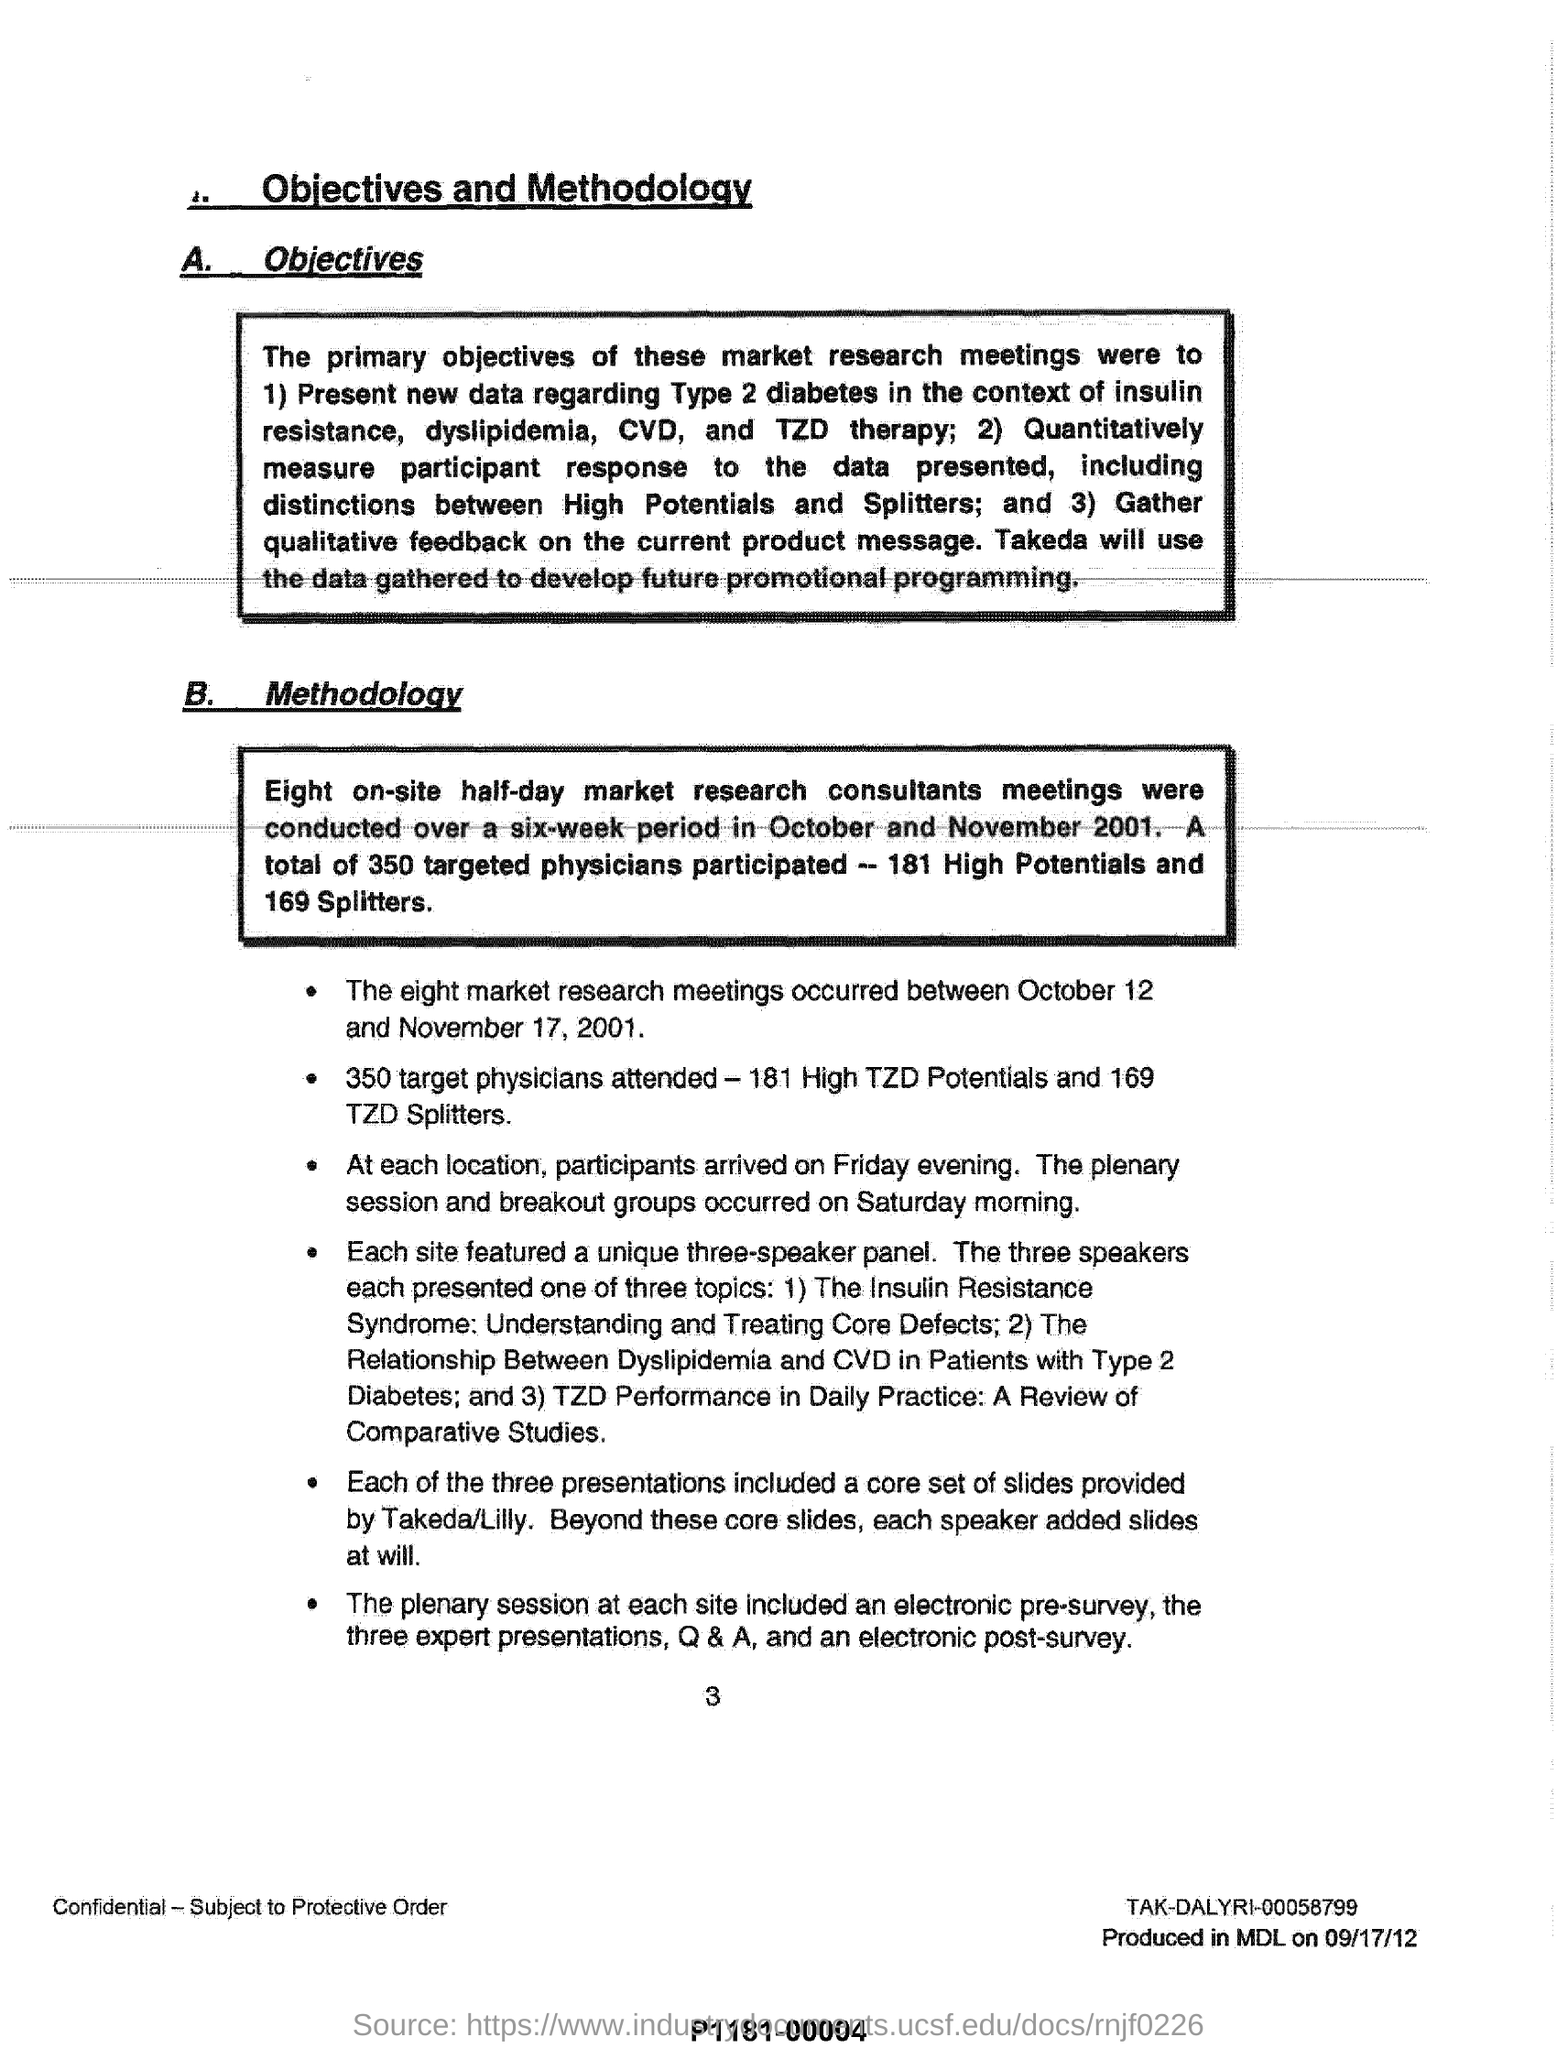What is the title of this page?
Provide a succinct answer. OBJECTIVES AND METHODOLOGY. 